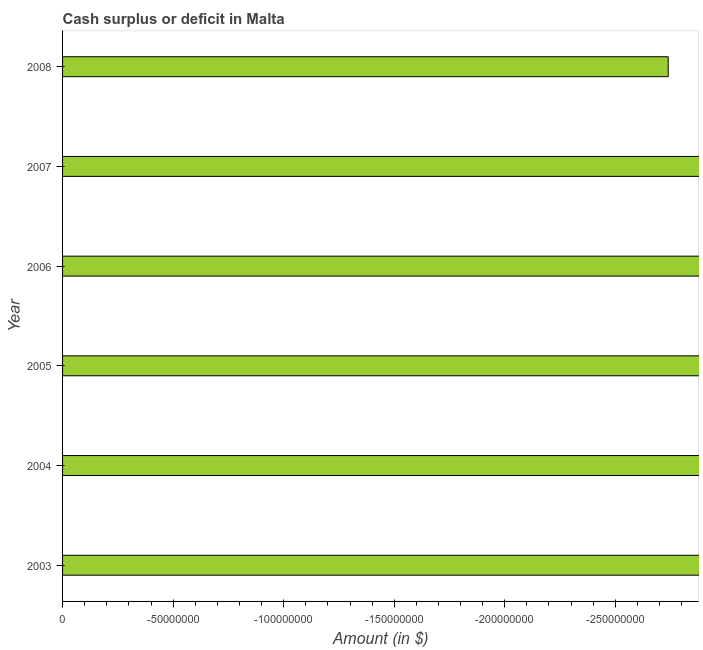Does the graph contain grids?
Your answer should be compact. No. What is the title of the graph?
Make the answer very short. Cash surplus or deficit in Malta. What is the label or title of the X-axis?
Ensure brevity in your answer.  Amount (in $). What is the label or title of the Y-axis?
Your answer should be very brief. Year. Across all years, what is the minimum cash surplus or deficit?
Offer a terse response. 0. What is the sum of the cash surplus or deficit?
Provide a short and direct response. 0. In how many years, is the cash surplus or deficit greater than -190000000 $?
Provide a succinct answer. 0. In how many years, is the cash surplus or deficit greater than the average cash surplus or deficit taken over all years?
Provide a short and direct response. 0. Are all the bars in the graph horizontal?
Provide a short and direct response. Yes. Are the values on the major ticks of X-axis written in scientific E-notation?
Offer a very short reply. No. What is the Amount (in $) of 2005?
Ensure brevity in your answer.  0. What is the Amount (in $) in 2006?
Ensure brevity in your answer.  0. 